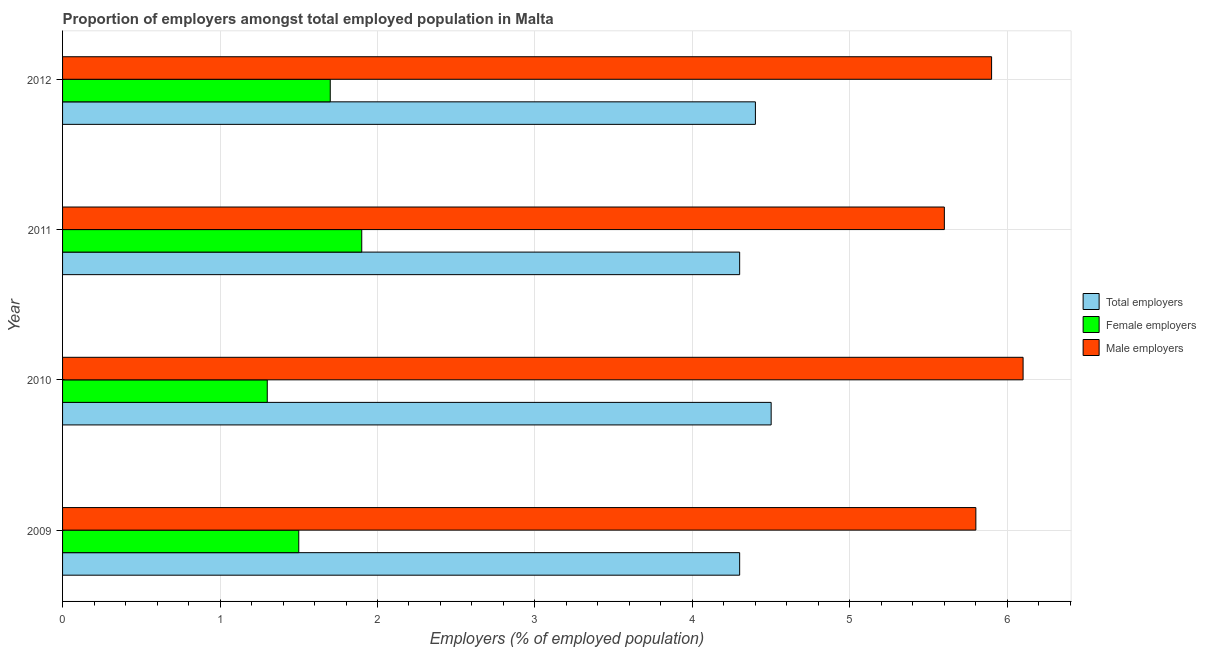How many different coloured bars are there?
Your answer should be compact. 3. How many groups of bars are there?
Offer a terse response. 4. Are the number of bars on each tick of the Y-axis equal?
Keep it short and to the point. Yes. What is the label of the 4th group of bars from the top?
Keep it short and to the point. 2009. In how many cases, is the number of bars for a given year not equal to the number of legend labels?
Offer a terse response. 0. Across all years, what is the maximum percentage of male employers?
Keep it short and to the point. 6.1. Across all years, what is the minimum percentage of male employers?
Offer a terse response. 5.6. What is the total percentage of total employers in the graph?
Your response must be concise. 17.5. What is the difference between the percentage of male employers in 2010 and that in 2012?
Your response must be concise. 0.2. What is the difference between the percentage of female employers in 2011 and the percentage of male employers in 2010?
Provide a succinct answer. -4.2. What is the average percentage of total employers per year?
Give a very brief answer. 4.38. In how many years, is the percentage of male employers greater than 6.2 %?
Give a very brief answer. 0. What is the ratio of the percentage of female employers in 2010 to that in 2011?
Offer a terse response. 0.68. Is the percentage of female employers in 2009 less than that in 2010?
Offer a terse response. No. What is the difference between the highest and the second highest percentage of male employers?
Keep it short and to the point. 0.2. Is the sum of the percentage of total employers in 2009 and 2012 greater than the maximum percentage of female employers across all years?
Your answer should be compact. Yes. What does the 1st bar from the top in 2012 represents?
Your answer should be compact. Male employers. What does the 3rd bar from the bottom in 2010 represents?
Your answer should be very brief. Male employers. Are all the bars in the graph horizontal?
Ensure brevity in your answer.  Yes. Are the values on the major ticks of X-axis written in scientific E-notation?
Your answer should be compact. No. Does the graph contain grids?
Give a very brief answer. Yes. Where does the legend appear in the graph?
Ensure brevity in your answer.  Center right. How many legend labels are there?
Provide a succinct answer. 3. What is the title of the graph?
Offer a very short reply. Proportion of employers amongst total employed population in Malta. What is the label or title of the X-axis?
Offer a very short reply. Employers (% of employed population). What is the Employers (% of employed population) in Total employers in 2009?
Your response must be concise. 4.3. What is the Employers (% of employed population) in Female employers in 2009?
Your response must be concise. 1.5. What is the Employers (% of employed population) in Male employers in 2009?
Offer a terse response. 5.8. What is the Employers (% of employed population) of Female employers in 2010?
Provide a short and direct response. 1.3. What is the Employers (% of employed population) in Male employers in 2010?
Give a very brief answer. 6.1. What is the Employers (% of employed population) in Total employers in 2011?
Provide a short and direct response. 4.3. What is the Employers (% of employed population) of Female employers in 2011?
Provide a short and direct response. 1.9. What is the Employers (% of employed population) in Male employers in 2011?
Your response must be concise. 5.6. What is the Employers (% of employed population) of Total employers in 2012?
Offer a terse response. 4.4. What is the Employers (% of employed population) of Female employers in 2012?
Your answer should be very brief. 1.7. What is the Employers (% of employed population) in Male employers in 2012?
Offer a terse response. 5.9. Across all years, what is the maximum Employers (% of employed population) of Female employers?
Ensure brevity in your answer.  1.9. Across all years, what is the maximum Employers (% of employed population) of Male employers?
Provide a short and direct response. 6.1. Across all years, what is the minimum Employers (% of employed population) in Total employers?
Your response must be concise. 4.3. Across all years, what is the minimum Employers (% of employed population) in Female employers?
Your response must be concise. 1.3. Across all years, what is the minimum Employers (% of employed population) in Male employers?
Your response must be concise. 5.6. What is the total Employers (% of employed population) of Male employers in the graph?
Your answer should be very brief. 23.4. What is the difference between the Employers (% of employed population) of Total employers in 2009 and that in 2010?
Ensure brevity in your answer.  -0.2. What is the difference between the Employers (% of employed population) of Male employers in 2009 and that in 2010?
Make the answer very short. -0.3. What is the difference between the Employers (% of employed population) of Female employers in 2009 and that in 2011?
Provide a short and direct response. -0.4. What is the difference between the Employers (% of employed population) in Male employers in 2009 and that in 2011?
Ensure brevity in your answer.  0.2. What is the difference between the Employers (% of employed population) in Male employers in 2010 and that in 2011?
Offer a terse response. 0.5. What is the difference between the Employers (% of employed population) in Female employers in 2010 and that in 2012?
Provide a short and direct response. -0.4. What is the difference between the Employers (% of employed population) of Male employers in 2010 and that in 2012?
Provide a short and direct response. 0.2. What is the difference between the Employers (% of employed population) in Total employers in 2011 and that in 2012?
Your answer should be compact. -0.1. What is the difference between the Employers (% of employed population) of Female employers in 2011 and that in 2012?
Make the answer very short. 0.2. What is the difference between the Employers (% of employed population) in Total employers in 2009 and the Employers (% of employed population) in Female employers in 2011?
Offer a terse response. 2.4. What is the difference between the Employers (% of employed population) in Total employers in 2009 and the Employers (% of employed population) in Male employers in 2011?
Ensure brevity in your answer.  -1.3. What is the difference between the Employers (% of employed population) of Total employers in 2009 and the Employers (% of employed population) of Male employers in 2012?
Give a very brief answer. -1.6. What is the difference between the Employers (% of employed population) in Female employers in 2009 and the Employers (% of employed population) in Male employers in 2012?
Give a very brief answer. -4.4. What is the difference between the Employers (% of employed population) of Total employers in 2010 and the Employers (% of employed population) of Male employers in 2011?
Give a very brief answer. -1.1. What is the difference between the Employers (% of employed population) of Female employers in 2010 and the Employers (% of employed population) of Male employers in 2012?
Offer a terse response. -4.6. What is the difference between the Employers (% of employed population) of Total employers in 2011 and the Employers (% of employed population) of Male employers in 2012?
Offer a very short reply. -1.6. What is the difference between the Employers (% of employed population) in Female employers in 2011 and the Employers (% of employed population) in Male employers in 2012?
Your response must be concise. -4. What is the average Employers (% of employed population) of Total employers per year?
Offer a very short reply. 4.38. What is the average Employers (% of employed population) in Female employers per year?
Ensure brevity in your answer.  1.6. What is the average Employers (% of employed population) of Male employers per year?
Make the answer very short. 5.85. In the year 2009, what is the difference between the Employers (% of employed population) of Total employers and Employers (% of employed population) of Female employers?
Your answer should be very brief. 2.8. In the year 2009, what is the difference between the Employers (% of employed population) in Total employers and Employers (% of employed population) in Male employers?
Your answer should be compact. -1.5. In the year 2010, what is the difference between the Employers (% of employed population) in Female employers and Employers (% of employed population) in Male employers?
Provide a short and direct response. -4.8. In the year 2011, what is the difference between the Employers (% of employed population) of Female employers and Employers (% of employed population) of Male employers?
Ensure brevity in your answer.  -3.7. In the year 2012, what is the difference between the Employers (% of employed population) of Total employers and Employers (% of employed population) of Female employers?
Give a very brief answer. 2.7. In the year 2012, what is the difference between the Employers (% of employed population) of Female employers and Employers (% of employed population) of Male employers?
Your answer should be very brief. -4.2. What is the ratio of the Employers (% of employed population) of Total employers in 2009 to that in 2010?
Ensure brevity in your answer.  0.96. What is the ratio of the Employers (% of employed population) in Female employers in 2009 to that in 2010?
Offer a terse response. 1.15. What is the ratio of the Employers (% of employed population) of Male employers in 2009 to that in 2010?
Offer a very short reply. 0.95. What is the ratio of the Employers (% of employed population) of Female employers in 2009 to that in 2011?
Keep it short and to the point. 0.79. What is the ratio of the Employers (% of employed population) of Male employers in 2009 to that in 2011?
Your answer should be very brief. 1.04. What is the ratio of the Employers (% of employed population) in Total employers in 2009 to that in 2012?
Provide a short and direct response. 0.98. What is the ratio of the Employers (% of employed population) in Female employers in 2009 to that in 2012?
Make the answer very short. 0.88. What is the ratio of the Employers (% of employed population) of Male employers in 2009 to that in 2012?
Make the answer very short. 0.98. What is the ratio of the Employers (% of employed population) in Total employers in 2010 to that in 2011?
Your answer should be compact. 1.05. What is the ratio of the Employers (% of employed population) of Female employers in 2010 to that in 2011?
Offer a terse response. 0.68. What is the ratio of the Employers (% of employed population) of Male employers in 2010 to that in 2011?
Offer a terse response. 1.09. What is the ratio of the Employers (% of employed population) of Total employers in 2010 to that in 2012?
Your response must be concise. 1.02. What is the ratio of the Employers (% of employed population) in Female employers in 2010 to that in 2012?
Make the answer very short. 0.76. What is the ratio of the Employers (% of employed population) of Male employers in 2010 to that in 2012?
Provide a succinct answer. 1.03. What is the ratio of the Employers (% of employed population) of Total employers in 2011 to that in 2012?
Give a very brief answer. 0.98. What is the ratio of the Employers (% of employed population) in Female employers in 2011 to that in 2012?
Keep it short and to the point. 1.12. What is the ratio of the Employers (% of employed population) in Male employers in 2011 to that in 2012?
Your answer should be very brief. 0.95. 